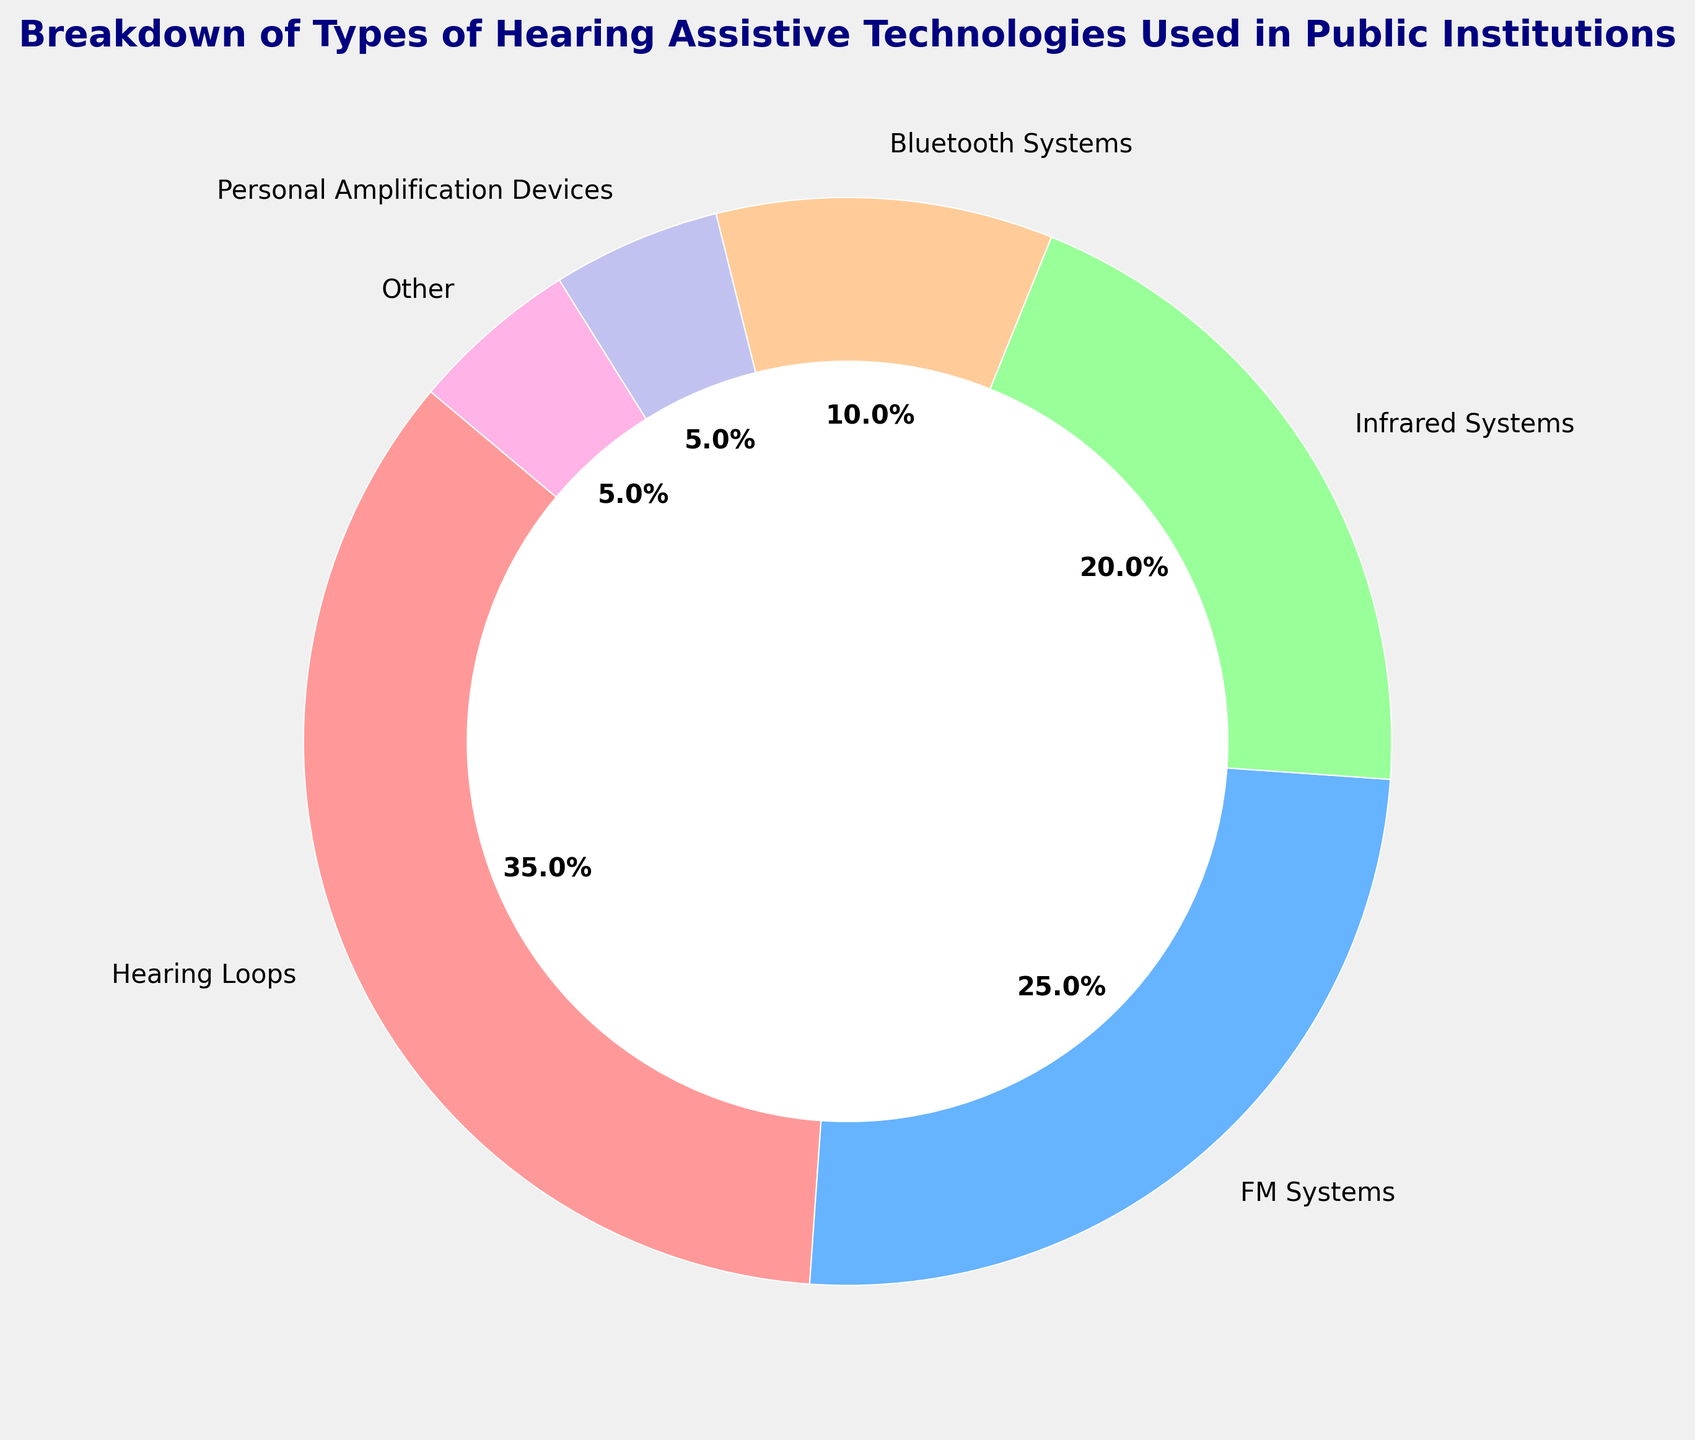What percentage of public institutions use FM Systems? Look at the chart and find the segment labeled "FM Systems." The percentage shown for FM Systems is 25%.
Answer: 25% Which hearing assistive technology is least used in public institutions? In the chart, the segments labeled "Personal Amplification Devices" and "Other" both have the smallest percentage, which is 5%.
Answer: Personal Amplification Devices and Other How much more popular are Hearing Loops compared to Bluetooth Systems? The percentage for Hearing Loops is 35% and for Bluetooth Systems is 10%. Subtract 10% from 35% to find the difference. 35% - 10% = 25%.
Answer: 25% What is the combined percentage of personal amplification devices and infrared systems? The segment percentage of Personal Amplification Devices is 5% and Infrared Systems is 20%. Add these two percentages together: 5% + 20% = 25%.
Answer: 25% Which technology is more commonly used: Infrared Systems or Bluetooth Systems? Compare the percentages: Infrared Systems are at 20%, and Bluetooth Systems are at 10%. Infrared Systems are more commonly used.
Answer: Infrared Systems Arrange the technologies from most used to least used. By observing the segment sizes and their labels: Hearing Loops (35%), FM Systems (25%), Infrared Systems (20%), Bluetooth Systems (10%), Personal Amplification Devices (5%), Other (5%).
Answer: Hearing Loops, FM Systems, Infrared Systems, Bluetooth Systems, Personal Amplification Devices, Other What is the percentage difference between FM Systems and Infrared Systems? The percentage for FM Systems is 25% and for Infrared Systems is 20%. Subtract 20% from 25% to get the difference: 25% - 20% = 5%.
Answer: 5% What is the total percentage of all other technologies except Hearing Loops? Sum the percentages of all other technologies: FM Systems (25%), Infrared Systems (20%), Bluetooth Systems (10%), Personal Amplification Devices (5%), Other (5%). 25% + 20% + 10% + 5% + 5% = 65%.
Answer: 65% Which segments are represented with shades of red in the pie chart? Look for segments with shades of red. "Hearing Loops" and "Other" are likely represented in shades of red based on common visual design choices.
Answer: Hearing Loops, Other What is the average percentage of all the categories combined? Add all the percentages and divide by the number of categories: (35% + 25% + 20% + 10% + 5% + 5%) / 6. That's 100% / 6 = 16.67%.
Answer: 16.67% 